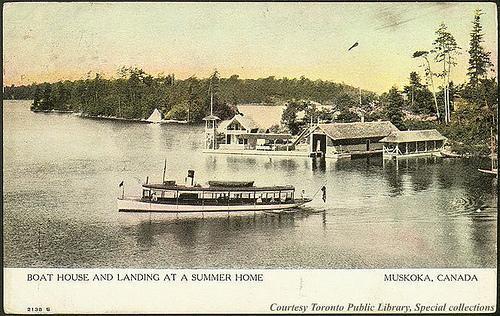How many boats are pictured?
Give a very brief answer. 1. 